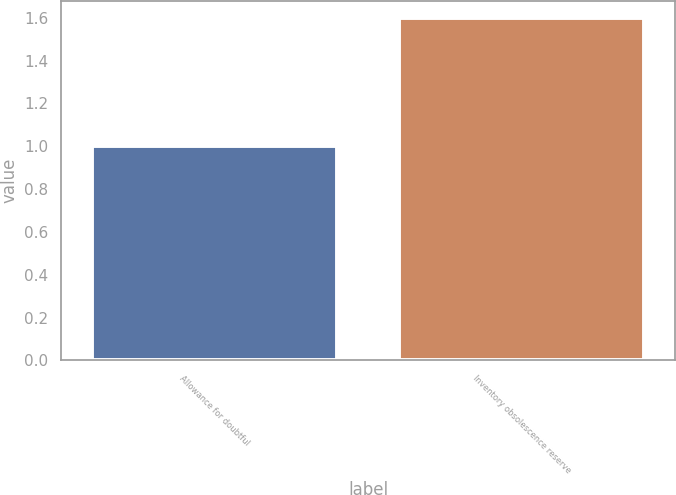<chart> <loc_0><loc_0><loc_500><loc_500><bar_chart><fcel>Allowance for doubtful<fcel>Inventory obsolescence reserve<nl><fcel>1<fcel>1.6<nl></chart> 